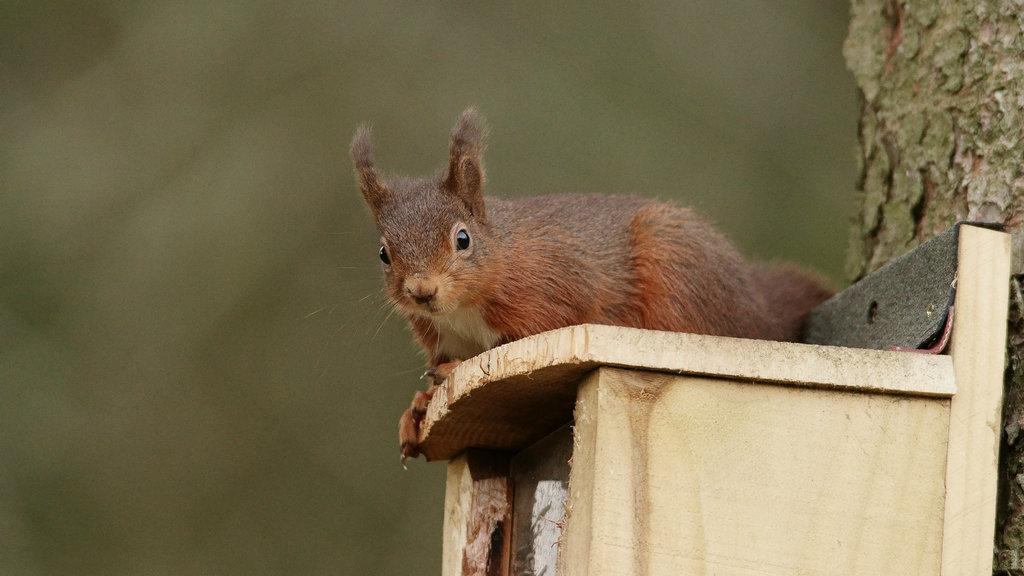What animal is sitting on the bench in the image? There is a rabbit on a bench in the image. What other object can be seen in the image besides the bench and the rabbit? There is a tree trunk in the image. Can you describe the background of the image? The background of the image is not clear. Based on the lighting and visibility, when do you think the image was taken? The image was likely taken during the day. What type of music is the rabbit listening to on the bench? There is no indication in the image that the rabbit is listening to music, so it cannot be determined from the picture. 